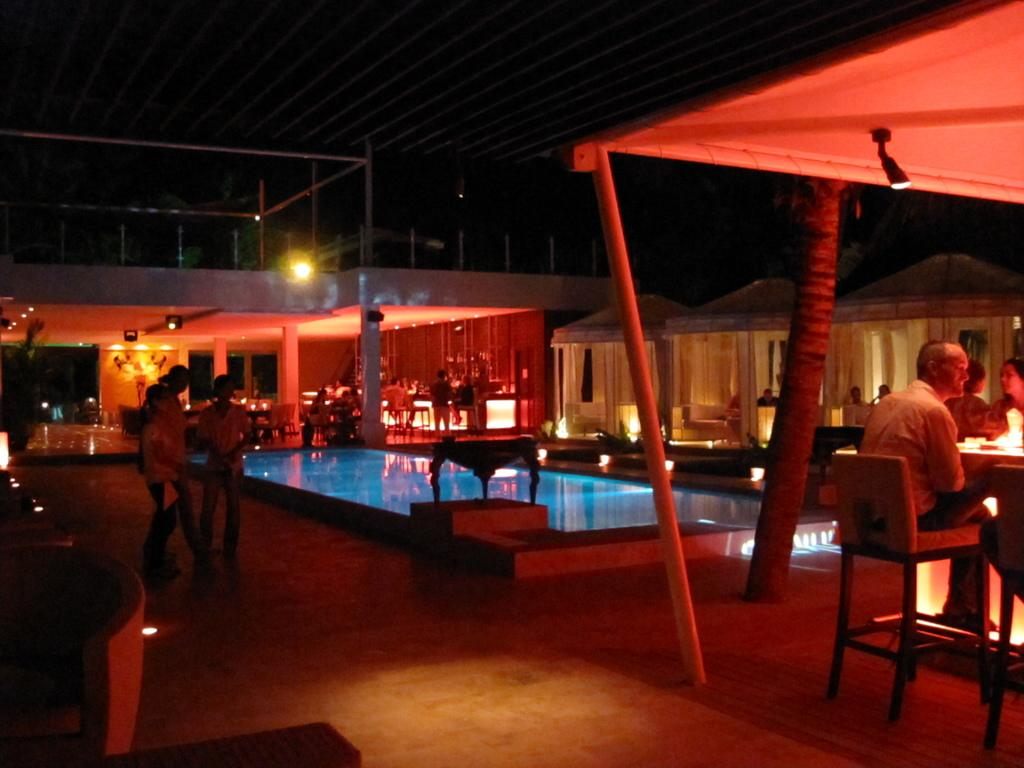What are the people sitting on in the image? People are sitting on chairs under tents in the image. What is located behind the people sitting on chairs? There is a pool behind the people sitting on chairs. What is situated behind the pool? There is a building behind the pool. What is happening on the left side of the image? People are standing at the left side of the image. What time of day is depicted in the image? It is nighttime in the image. How many police officers are visible in the image? There are no police officers present in the image. What type of bird can be seen perched on the hand of a person in the image? There is no bird or hand present in the image. 